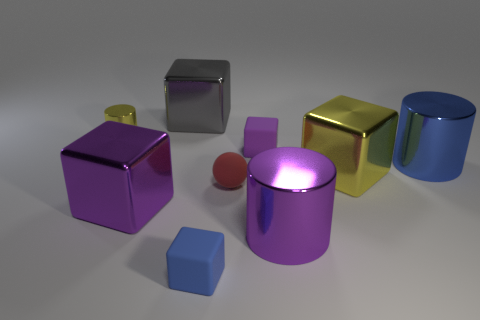There is a large metal thing that is left of the yellow metallic block and on the right side of the blue matte block; what is its shape?
Offer a very short reply. Cylinder. What size is the metal cube behind the big blue metal object?
Provide a succinct answer. Large. There is a purple shiny object that is in front of the purple block that is on the left side of the gray block; how many shiny cylinders are in front of it?
Ensure brevity in your answer.  0. There is a big yellow block; are there any yellow cubes to the right of it?
Offer a very short reply. No. How many other objects are there of the same size as the blue metal thing?
Your answer should be very brief. 4. The big thing that is both to the left of the red matte sphere and in front of the gray metallic thing is made of what material?
Your answer should be compact. Metal. Does the yellow object that is in front of the tiny purple matte object have the same shape as the small shiny object that is in front of the large gray cube?
Offer a very short reply. No. The yellow thing in front of the shiny cylinder that is right of the large metal block that is to the right of the small blue object is what shape?
Provide a short and direct response. Cube. What number of other things are there of the same shape as the gray object?
Provide a short and direct response. 4. What color is the other metal thing that is the same size as the red object?
Provide a short and direct response. Yellow. 